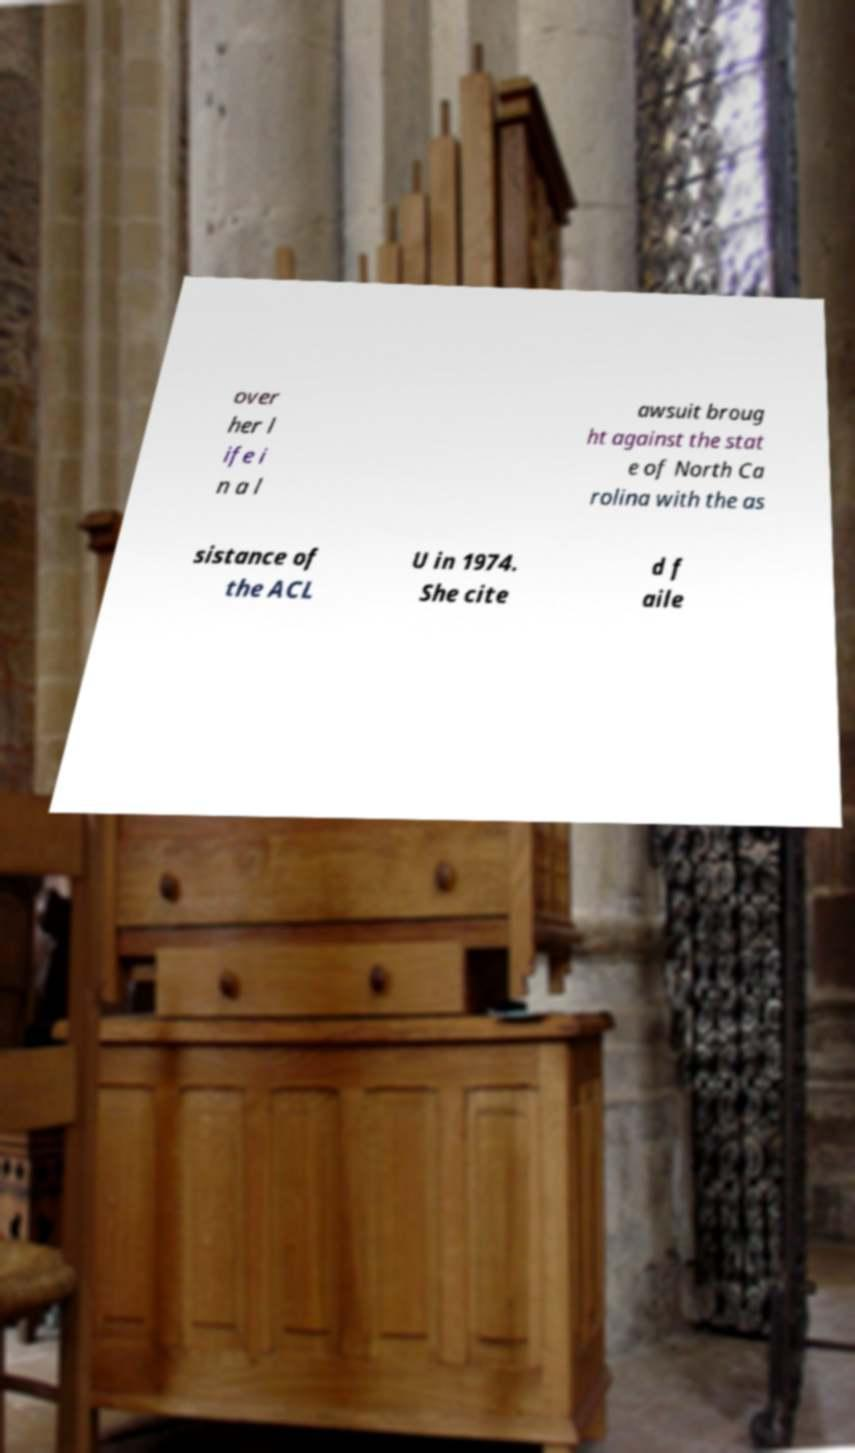Can you read and provide the text displayed in the image?This photo seems to have some interesting text. Can you extract and type it out for me? over her l ife i n a l awsuit broug ht against the stat e of North Ca rolina with the as sistance of the ACL U in 1974. She cite d f aile 